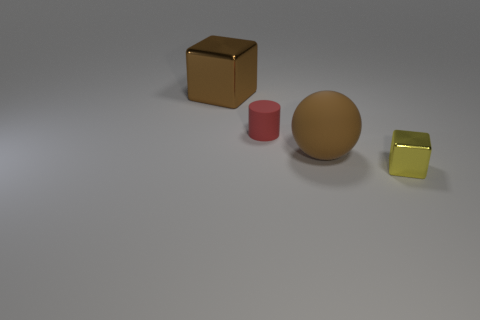Subtract all blue cylinders. Subtract all purple balls. How many cylinders are left? 1 Subtract all brown blocks. How many gray balls are left? 0 Add 4 small objects. How many browns exist? 0 Subtract all large purple metal cylinders. Subtract all tiny red things. How many objects are left? 3 Add 4 large brown shiny objects. How many large brown shiny objects are left? 5 Add 4 big spheres. How many big spheres exist? 5 Add 4 small cylinders. How many objects exist? 8 Subtract all brown blocks. How many blocks are left? 1 Subtract 0 red blocks. How many objects are left? 4 Subtract all balls. How many objects are left? 3 